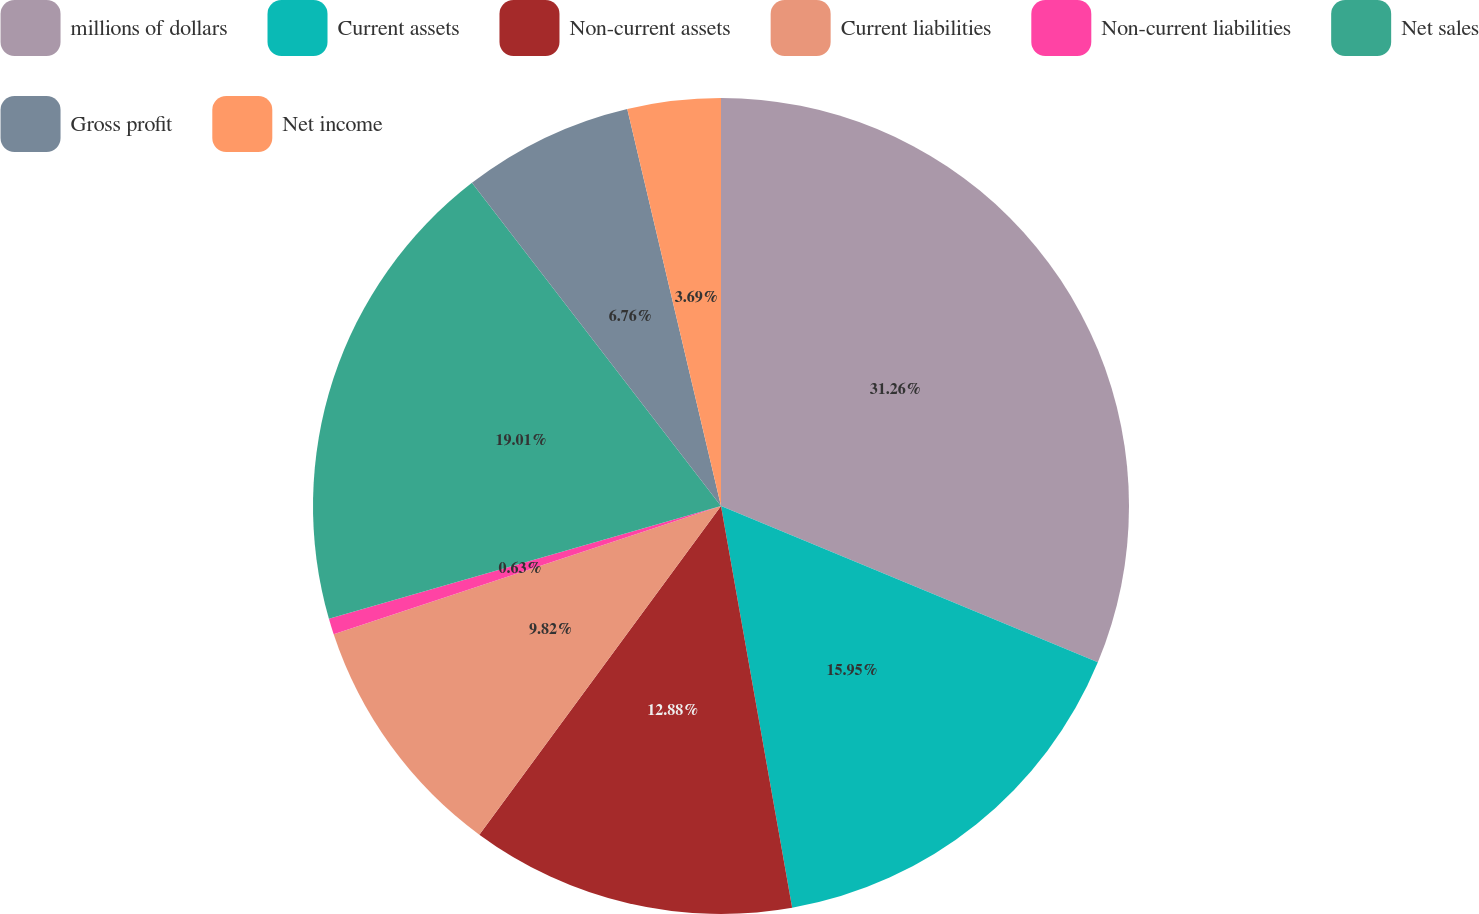Convert chart. <chart><loc_0><loc_0><loc_500><loc_500><pie_chart><fcel>millions of dollars<fcel>Current assets<fcel>Non-current assets<fcel>Current liabilities<fcel>Non-current liabilities<fcel>Net sales<fcel>Gross profit<fcel>Net income<nl><fcel>31.26%<fcel>15.95%<fcel>12.88%<fcel>9.82%<fcel>0.63%<fcel>19.01%<fcel>6.76%<fcel>3.69%<nl></chart> 